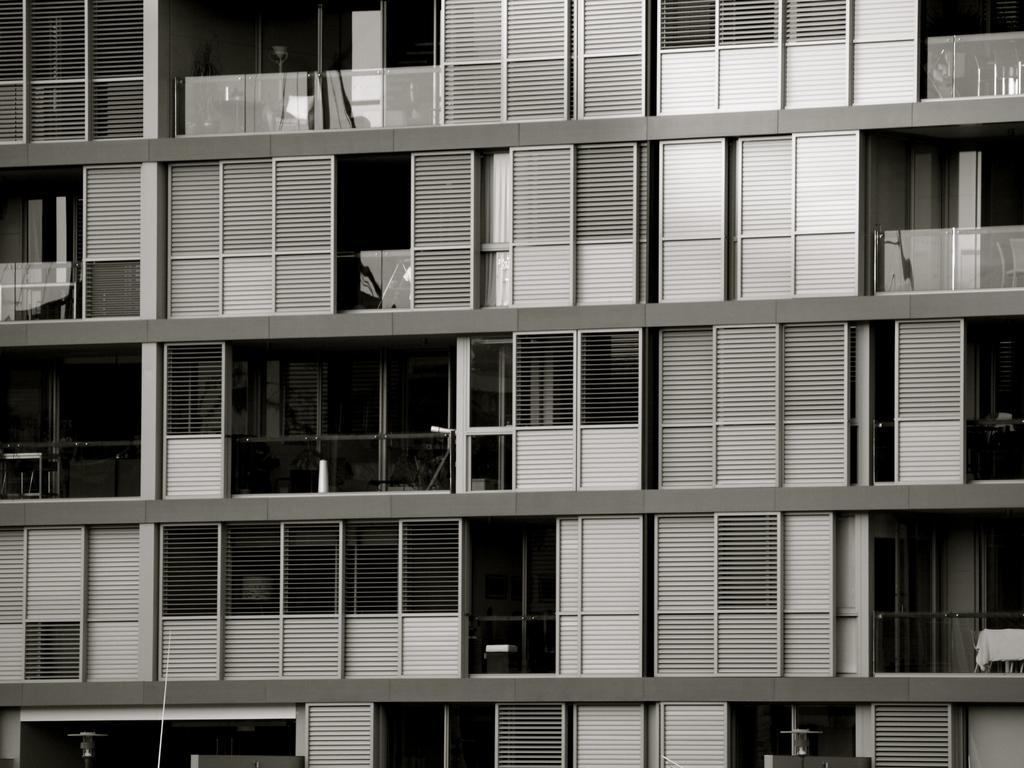Can you describe this image briefly? In this picture we can observe a building. There are some glass doors. This is a black and white image. 